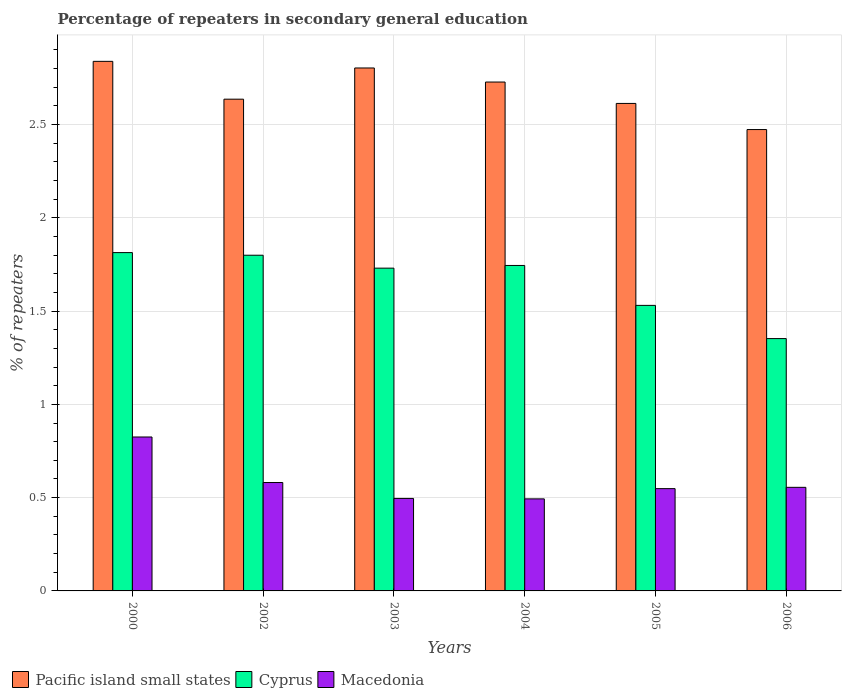How many different coloured bars are there?
Provide a succinct answer. 3. How many groups of bars are there?
Give a very brief answer. 6. Are the number of bars per tick equal to the number of legend labels?
Give a very brief answer. Yes. Are the number of bars on each tick of the X-axis equal?
Your answer should be very brief. Yes. What is the label of the 1st group of bars from the left?
Your answer should be compact. 2000. What is the percentage of repeaters in secondary general education in Pacific island small states in 2004?
Offer a very short reply. 2.73. Across all years, what is the maximum percentage of repeaters in secondary general education in Cyprus?
Your answer should be very brief. 1.81. Across all years, what is the minimum percentage of repeaters in secondary general education in Macedonia?
Keep it short and to the point. 0.49. In which year was the percentage of repeaters in secondary general education in Pacific island small states maximum?
Ensure brevity in your answer.  2000. What is the total percentage of repeaters in secondary general education in Pacific island small states in the graph?
Your answer should be compact. 16.09. What is the difference between the percentage of repeaters in secondary general education in Macedonia in 2004 and that in 2005?
Offer a very short reply. -0.05. What is the difference between the percentage of repeaters in secondary general education in Macedonia in 2002 and the percentage of repeaters in secondary general education in Pacific island small states in 2004?
Offer a terse response. -2.15. What is the average percentage of repeaters in secondary general education in Macedonia per year?
Offer a very short reply. 0.58. In the year 2000, what is the difference between the percentage of repeaters in secondary general education in Cyprus and percentage of repeaters in secondary general education in Pacific island small states?
Ensure brevity in your answer.  -1.03. What is the ratio of the percentage of repeaters in secondary general education in Pacific island small states in 2002 to that in 2003?
Ensure brevity in your answer.  0.94. Is the percentage of repeaters in secondary general education in Cyprus in 2004 less than that in 2005?
Your answer should be very brief. No. What is the difference between the highest and the second highest percentage of repeaters in secondary general education in Cyprus?
Give a very brief answer. 0.01. What is the difference between the highest and the lowest percentage of repeaters in secondary general education in Pacific island small states?
Ensure brevity in your answer.  0.37. In how many years, is the percentage of repeaters in secondary general education in Cyprus greater than the average percentage of repeaters in secondary general education in Cyprus taken over all years?
Make the answer very short. 4. What does the 3rd bar from the left in 2002 represents?
Offer a very short reply. Macedonia. What does the 3rd bar from the right in 2003 represents?
Offer a terse response. Pacific island small states. Is it the case that in every year, the sum of the percentage of repeaters in secondary general education in Cyprus and percentage of repeaters in secondary general education in Pacific island small states is greater than the percentage of repeaters in secondary general education in Macedonia?
Your response must be concise. Yes. How many bars are there?
Ensure brevity in your answer.  18. Are the values on the major ticks of Y-axis written in scientific E-notation?
Offer a terse response. No. Does the graph contain any zero values?
Make the answer very short. No. Where does the legend appear in the graph?
Make the answer very short. Bottom left. How many legend labels are there?
Your answer should be compact. 3. What is the title of the graph?
Your response must be concise. Percentage of repeaters in secondary general education. Does "Malaysia" appear as one of the legend labels in the graph?
Offer a terse response. No. What is the label or title of the Y-axis?
Give a very brief answer. % of repeaters. What is the % of repeaters of Pacific island small states in 2000?
Keep it short and to the point. 2.84. What is the % of repeaters of Cyprus in 2000?
Provide a succinct answer. 1.81. What is the % of repeaters of Macedonia in 2000?
Offer a terse response. 0.83. What is the % of repeaters in Pacific island small states in 2002?
Give a very brief answer. 2.64. What is the % of repeaters of Cyprus in 2002?
Provide a short and direct response. 1.8. What is the % of repeaters of Macedonia in 2002?
Provide a short and direct response. 0.58. What is the % of repeaters of Pacific island small states in 2003?
Ensure brevity in your answer.  2.8. What is the % of repeaters of Cyprus in 2003?
Ensure brevity in your answer.  1.73. What is the % of repeaters of Macedonia in 2003?
Provide a short and direct response. 0.5. What is the % of repeaters in Pacific island small states in 2004?
Make the answer very short. 2.73. What is the % of repeaters of Cyprus in 2004?
Keep it short and to the point. 1.74. What is the % of repeaters in Macedonia in 2004?
Provide a succinct answer. 0.49. What is the % of repeaters in Pacific island small states in 2005?
Give a very brief answer. 2.61. What is the % of repeaters of Cyprus in 2005?
Ensure brevity in your answer.  1.53. What is the % of repeaters of Macedonia in 2005?
Give a very brief answer. 0.55. What is the % of repeaters in Pacific island small states in 2006?
Ensure brevity in your answer.  2.47. What is the % of repeaters in Cyprus in 2006?
Offer a terse response. 1.35. What is the % of repeaters in Macedonia in 2006?
Provide a succinct answer. 0.56. Across all years, what is the maximum % of repeaters in Pacific island small states?
Keep it short and to the point. 2.84. Across all years, what is the maximum % of repeaters of Cyprus?
Offer a very short reply. 1.81. Across all years, what is the maximum % of repeaters in Macedonia?
Provide a short and direct response. 0.83. Across all years, what is the minimum % of repeaters in Pacific island small states?
Offer a very short reply. 2.47. Across all years, what is the minimum % of repeaters of Cyprus?
Provide a short and direct response. 1.35. Across all years, what is the minimum % of repeaters in Macedonia?
Your answer should be compact. 0.49. What is the total % of repeaters in Pacific island small states in the graph?
Make the answer very short. 16.09. What is the total % of repeaters of Cyprus in the graph?
Give a very brief answer. 9.97. What is the total % of repeaters of Macedonia in the graph?
Make the answer very short. 3.5. What is the difference between the % of repeaters in Pacific island small states in 2000 and that in 2002?
Your response must be concise. 0.2. What is the difference between the % of repeaters of Cyprus in 2000 and that in 2002?
Provide a short and direct response. 0.01. What is the difference between the % of repeaters of Macedonia in 2000 and that in 2002?
Offer a very short reply. 0.24. What is the difference between the % of repeaters of Pacific island small states in 2000 and that in 2003?
Your answer should be compact. 0.04. What is the difference between the % of repeaters in Cyprus in 2000 and that in 2003?
Give a very brief answer. 0.08. What is the difference between the % of repeaters in Macedonia in 2000 and that in 2003?
Your response must be concise. 0.33. What is the difference between the % of repeaters in Pacific island small states in 2000 and that in 2004?
Provide a short and direct response. 0.11. What is the difference between the % of repeaters of Cyprus in 2000 and that in 2004?
Your answer should be compact. 0.07. What is the difference between the % of repeaters of Macedonia in 2000 and that in 2004?
Offer a very short reply. 0.33. What is the difference between the % of repeaters in Pacific island small states in 2000 and that in 2005?
Ensure brevity in your answer.  0.23. What is the difference between the % of repeaters in Cyprus in 2000 and that in 2005?
Your answer should be compact. 0.28. What is the difference between the % of repeaters in Macedonia in 2000 and that in 2005?
Give a very brief answer. 0.28. What is the difference between the % of repeaters of Pacific island small states in 2000 and that in 2006?
Give a very brief answer. 0.37. What is the difference between the % of repeaters in Cyprus in 2000 and that in 2006?
Offer a terse response. 0.46. What is the difference between the % of repeaters in Macedonia in 2000 and that in 2006?
Ensure brevity in your answer.  0.27. What is the difference between the % of repeaters of Pacific island small states in 2002 and that in 2003?
Make the answer very short. -0.17. What is the difference between the % of repeaters in Cyprus in 2002 and that in 2003?
Provide a short and direct response. 0.07. What is the difference between the % of repeaters of Macedonia in 2002 and that in 2003?
Offer a terse response. 0.09. What is the difference between the % of repeaters in Pacific island small states in 2002 and that in 2004?
Make the answer very short. -0.09. What is the difference between the % of repeaters in Cyprus in 2002 and that in 2004?
Provide a succinct answer. 0.05. What is the difference between the % of repeaters in Macedonia in 2002 and that in 2004?
Offer a very short reply. 0.09. What is the difference between the % of repeaters of Pacific island small states in 2002 and that in 2005?
Ensure brevity in your answer.  0.02. What is the difference between the % of repeaters of Cyprus in 2002 and that in 2005?
Provide a short and direct response. 0.27. What is the difference between the % of repeaters in Macedonia in 2002 and that in 2005?
Give a very brief answer. 0.03. What is the difference between the % of repeaters of Pacific island small states in 2002 and that in 2006?
Ensure brevity in your answer.  0.16. What is the difference between the % of repeaters in Cyprus in 2002 and that in 2006?
Offer a very short reply. 0.45. What is the difference between the % of repeaters of Macedonia in 2002 and that in 2006?
Provide a succinct answer. 0.03. What is the difference between the % of repeaters in Pacific island small states in 2003 and that in 2004?
Give a very brief answer. 0.08. What is the difference between the % of repeaters of Cyprus in 2003 and that in 2004?
Ensure brevity in your answer.  -0.01. What is the difference between the % of repeaters of Macedonia in 2003 and that in 2004?
Offer a very short reply. 0. What is the difference between the % of repeaters in Pacific island small states in 2003 and that in 2005?
Give a very brief answer. 0.19. What is the difference between the % of repeaters of Cyprus in 2003 and that in 2005?
Your answer should be compact. 0.2. What is the difference between the % of repeaters of Macedonia in 2003 and that in 2005?
Give a very brief answer. -0.05. What is the difference between the % of repeaters of Pacific island small states in 2003 and that in 2006?
Your answer should be very brief. 0.33. What is the difference between the % of repeaters in Cyprus in 2003 and that in 2006?
Your response must be concise. 0.38. What is the difference between the % of repeaters in Macedonia in 2003 and that in 2006?
Give a very brief answer. -0.06. What is the difference between the % of repeaters of Pacific island small states in 2004 and that in 2005?
Ensure brevity in your answer.  0.11. What is the difference between the % of repeaters of Cyprus in 2004 and that in 2005?
Keep it short and to the point. 0.21. What is the difference between the % of repeaters of Macedonia in 2004 and that in 2005?
Make the answer very short. -0.05. What is the difference between the % of repeaters of Pacific island small states in 2004 and that in 2006?
Your response must be concise. 0.25. What is the difference between the % of repeaters of Cyprus in 2004 and that in 2006?
Provide a short and direct response. 0.39. What is the difference between the % of repeaters of Macedonia in 2004 and that in 2006?
Your answer should be compact. -0.06. What is the difference between the % of repeaters of Pacific island small states in 2005 and that in 2006?
Your answer should be compact. 0.14. What is the difference between the % of repeaters in Cyprus in 2005 and that in 2006?
Provide a short and direct response. 0.18. What is the difference between the % of repeaters in Macedonia in 2005 and that in 2006?
Offer a very short reply. -0.01. What is the difference between the % of repeaters of Pacific island small states in 2000 and the % of repeaters of Cyprus in 2002?
Ensure brevity in your answer.  1.04. What is the difference between the % of repeaters in Pacific island small states in 2000 and the % of repeaters in Macedonia in 2002?
Keep it short and to the point. 2.26. What is the difference between the % of repeaters of Cyprus in 2000 and the % of repeaters of Macedonia in 2002?
Your response must be concise. 1.23. What is the difference between the % of repeaters in Pacific island small states in 2000 and the % of repeaters in Cyprus in 2003?
Ensure brevity in your answer.  1.11. What is the difference between the % of repeaters of Pacific island small states in 2000 and the % of repeaters of Macedonia in 2003?
Your response must be concise. 2.34. What is the difference between the % of repeaters in Cyprus in 2000 and the % of repeaters in Macedonia in 2003?
Offer a terse response. 1.32. What is the difference between the % of repeaters of Pacific island small states in 2000 and the % of repeaters of Cyprus in 2004?
Make the answer very short. 1.09. What is the difference between the % of repeaters of Pacific island small states in 2000 and the % of repeaters of Macedonia in 2004?
Your response must be concise. 2.35. What is the difference between the % of repeaters in Cyprus in 2000 and the % of repeaters in Macedonia in 2004?
Ensure brevity in your answer.  1.32. What is the difference between the % of repeaters of Pacific island small states in 2000 and the % of repeaters of Cyprus in 2005?
Your answer should be compact. 1.31. What is the difference between the % of repeaters of Pacific island small states in 2000 and the % of repeaters of Macedonia in 2005?
Keep it short and to the point. 2.29. What is the difference between the % of repeaters of Cyprus in 2000 and the % of repeaters of Macedonia in 2005?
Offer a very short reply. 1.26. What is the difference between the % of repeaters in Pacific island small states in 2000 and the % of repeaters in Cyprus in 2006?
Your answer should be very brief. 1.49. What is the difference between the % of repeaters of Pacific island small states in 2000 and the % of repeaters of Macedonia in 2006?
Make the answer very short. 2.28. What is the difference between the % of repeaters of Cyprus in 2000 and the % of repeaters of Macedonia in 2006?
Your answer should be compact. 1.26. What is the difference between the % of repeaters in Pacific island small states in 2002 and the % of repeaters in Cyprus in 2003?
Keep it short and to the point. 0.91. What is the difference between the % of repeaters of Pacific island small states in 2002 and the % of repeaters of Macedonia in 2003?
Offer a very short reply. 2.14. What is the difference between the % of repeaters in Cyprus in 2002 and the % of repeaters in Macedonia in 2003?
Provide a succinct answer. 1.3. What is the difference between the % of repeaters in Pacific island small states in 2002 and the % of repeaters in Cyprus in 2004?
Give a very brief answer. 0.89. What is the difference between the % of repeaters in Pacific island small states in 2002 and the % of repeaters in Macedonia in 2004?
Your answer should be very brief. 2.14. What is the difference between the % of repeaters of Cyprus in 2002 and the % of repeaters of Macedonia in 2004?
Your answer should be compact. 1.31. What is the difference between the % of repeaters in Pacific island small states in 2002 and the % of repeaters in Cyprus in 2005?
Make the answer very short. 1.11. What is the difference between the % of repeaters of Pacific island small states in 2002 and the % of repeaters of Macedonia in 2005?
Your response must be concise. 2.09. What is the difference between the % of repeaters in Cyprus in 2002 and the % of repeaters in Macedonia in 2005?
Provide a short and direct response. 1.25. What is the difference between the % of repeaters of Pacific island small states in 2002 and the % of repeaters of Cyprus in 2006?
Make the answer very short. 1.28. What is the difference between the % of repeaters in Pacific island small states in 2002 and the % of repeaters in Macedonia in 2006?
Provide a short and direct response. 2.08. What is the difference between the % of repeaters in Cyprus in 2002 and the % of repeaters in Macedonia in 2006?
Provide a succinct answer. 1.24. What is the difference between the % of repeaters of Pacific island small states in 2003 and the % of repeaters of Cyprus in 2004?
Give a very brief answer. 1.06. What is the difference between the % of repeaters in Pacific island small states in 2003 and the % of repeaters in Macedonia in 2004?
Make the answer very short. 2.31. What is the difference between the % of repeaters of Cyprus in 2003 and the % of repeaters of Macedonia in 2004?
Keep it short and to the point. 1.24. What is the difference between the % of repeaters in Pacific island small states in 2003 and the % of repeaters in Cyprus in 2005?
Your answer should be compact. 1.27. What is the difference between the % of repeaters of Pacific island small states in 2003 and the % of repeaters of Macedonia in 2005?
Your answer should be very brief. 2.25. What is the difference between the % of repeaters of Cyprus in 2003 and the % of repeaters of Macedonia in 2005?
Ensure brevity in your answer.  1.18. What is the difference between the % of repeaters in Pacific island small states in 2003 and the % of repeaters in Cyprus in 2006?
Your answer should be compact. 1.45. What is the difference between the % of repeaters in Pacific island small states in 2003 and the % of repeaters in Macedonia in 2006?
Provide a short and direct response. 2.25. What is the difference between the % of repeaters in Cyprus in 2003 and the % of repeaters in Macedonia in 2006?
Offer a very short reply. 1.17. What is the difference between the % of repeaters of Pacific island small states in 2004 and the % of repeaters of Cyprus in 2005?
Offer a very short reply. 1.2. What is the difference between the % of repeaters in Pacific island small states in 2004 and the % of repeaters in Macedonia in 2005?
Your response must be concise. 2.18. What is the difference between the % of repeaters of Cyprus in 2004 and the % of repeaters of Macedonia in 2005?
Provide a short and direct response. 1.2. What is the difference between the % of repeaters in Pacific island small states in 2004 and the % of repeaters in Cyprus in 2006?
Keep it short and to the point. 1.38. What is the difference between the % of repeaters of Pacific island small states in 2004 and the % of repeaters of Macedonia in 2006?
Provide a short and direct response. 2.17. What is the difference between the % of repeaters in Cyprus in 2004 and the % of repeaters in Macedonia in 2006?
Offer a terse response. 1.19. What is the difference between the % of repeaters in Pacific island small states in 2005 and the % of repeaters in Cyprus in 2006?
Provide a succinct answer. 1.26. What is the difference between the % of repeaters in Pacific island small states in 2005 and the % of repeaters in Macedonia in 2006?
Make the answer very short. 2.06. What is the difference between the % of repeaters in Cyprus in 2005 and the % of repeaters in Macedonia in 2006?
Keep it short and to the point. 0.98. What is the average % of repeaters in Pacific island small states per year?
Provide a short and direct response. 2.68. What is the average % of repeaters of Cyprus per year?
Ensure brevity in your answer.  1.66. What is the average % of repeaters of Macedonia per year?
Provide a succinct answer. 0.58. In the year 2000, what is the difference between the % of repeaters of Pacific island small states and % of repeaters of Cyprus?
Keep it short and to the point. 1.02. In the year 2000, what is the difference between the % of repeaters in Pacific island small states and % of repeaters in Macedonia?
Your response must be concise. 2.01. In the year 2000, what is the difference between the % of repeaters of Cyprus and % of repeaters of Macedonia?
Keep it short and to the point. 0.99. In the year 2002, what is the difference between the % of repeaters of Pacific island small states and % of repeaters of Cyprus?
Keep it short and to the point. 0.84. In the year 2002, what is the difference between the % of repeaters of Pacific island small states and % of repeaters of Macedonia?
Your answer should be very brief. 2.05. In the year 2002, what is the difference between the % of repeaters of Cyprus and % of repeaters of Macedonia?
Ensure brevity in your answer.  1.22. In the year 2003, what is the difference between the % of repeaters of Pacific island small states and % of repeaters of Cyprus?
Ensure brevity in your answer.  1.07. In the year 2003, what is the difference between the % of repeaters in Pacific island small states and % of repeaters in Macedonia?
Keep it short and to the point. 2.31. In the year 2003, what is the difference between the % of repeaters in Cyprus and % of repeaters in Macedonia?
Provide a short and direct response. 1.23. In the year 2004, what is the difference between the % of repeaters in Pacific island small states and % of repeaters in Macedonia?
Make the answer very short. 2.23. In the year 2004, what is the difference between the % of repeaters of Cyprus and % of repeaters of Macedonia?
Offer a very short reply. 1.25. In the year 2005, what is the difference between the % of repeaters in Pacific island small states and % of repeaters in Cyprus?
Provide a short and direct response. 1.08. In the year 2005, what is the difference between the % of repeaters in Pacific island small states and % of repeaters in Macedonia?
Offer a very short reply. 2.06. In the year 2005, what is the difference between the % of repeaters of Cyprus and % of repeaters of Macedonia?
Provide a short and direct response. 0.98. In the year 2006, what is the difference between the % of repeaters in Pacific island small states and % of repeaters in Cyprus?
Give a very brief answer. 1.12. In the year 2006, what is the difference between the % of repeaters of Pacific island small states and % of repeaters of Macedonia?
Your response must be concise. 1.92. In the year 2006, what is the difference between the % of repeaters in Cyprus and % of repeaters in Macedonia?
Ensure brevity in your answer.  0.8. What is the ratio of the % of repeaters in Cyprus in 2000 to that in 2002?
Offer a very short reply. 1.01. What is the ratio of the % of repeaters in Macedonia in 2000 to that in 2002?
Offer a terse response. 1.42. What is the ratio of the % of repeaters in Pacific island small states in 2000 to that in 2003?
Your answer should be compact. 1.01. What is the ratio of the % of repeaters of Cyprus in 2000 to that in 2003?
Your response must be concise. 1.05. What is the ratio of the % of repeaters of Macedonia in 2000 to that in 2003?
Ensure brevity in your answer.  1.66. What is the ratio of the % of repeaters in Pacific island small states in 2000 to that in 2004?
Your answer should be very brief. 1.04. What is the ratio of the % of repeaters of Cyprus in 2000 to that in 2004?
Offer a very short reply. 1.04. What is the ratio of the % of repeaters of Macedonia in 2000 to that in 2004?
Offer a terse response. 1.67. What is the ratio of the % of repeaters of Pacific island small states in 2000 to that in 2005?
Offer a very short reply. 1.09. What is the ratio of the % of repeaters of Cyprus in 2000 to that in 2005?
Ensure brevity in your answer.  1.18. What is the ratio of the % of repeaters of Macedonia in 2000 to that in 2005?
Provide a short and direct response. 1.5. What is the ratio of the % of repeaters of Pacific island small states in 2000 to that in 2006?
Make the answer very short. 1.15. What is the ratio of the % of repeaters of Cyprus in 2000 to that in 2006?
Provide a short and direct response. 1.34. What is the ratio of the % of repeaters in Macedonia in 2000 to that in 2006?
Offer a very short reply. 1.49. What is the ratio of the % of repeaters of Pacific island small states in 2002 to that in 2003?
Provide a succinct answer. 0.94. What is the ratio of the % of repeaters in Cyprus in 2002 to that in 2003?
Ensure brevity in your answer.  1.04. What is the ratio of the % of repeaters in Macedonia in 2002 to that in 2003?
Your answer should be compact. 1.17. What is the ratio of the % of repeaters of Pacific island small states in 2002 to that in 2004?
Offer a terse response. 0.97. What is the ratio of the % of repeaters of Cyprus in 2002 to that in 2004?
Provide a short and direct response. 1.03. What is the ratio of the % of repeaters of Macedonia in 2002 to that in 2004?
Provide a short and direct response. 1.18. What is the ratio of the % of repeaters of Pacific island small states in 2002 to that in 2005?
Provide a succinct answer. 1.01. What is the ratio of the % of repeaters of Cyprus in 2002 to that in 2005?
Provide a short and direct response. 1.18. What is the ratio of the % of repeaters of Macedonia in 2002 to that in 2005?
Provide a succinct answer. 1.06. What is the ratio of the % of repeaters in Pacific island small states in 2002 to that in 2006?
Offer a terse response. 1.07. What is the ratio of the % of repeaters in Cyprus in 2002 to that in 2006?
Offer a very short reply. 1.33. What is the ratio of the % of repeaters in Macedonia in 2002 to that in 2006?
Ensure brevity in your answer.  1.05. What is the ratio of the % of repeaters of Pacific island small states in 2003 to that in 2004?
Your answer should be compact. 1.03. What is the ratio of the % of repeaters in Pacific island small states in 2003 to that in 2005?
Make the answer very short. 1.07. What is the ratio of the % of repeaters in Cyprus in 2003 to that in 2005?
Your answer should be very brief. 1.13. What is the ratio of the % of repeaters in Macedonia in 2003 to that in 2005?
Give a very brief answer. 0.9. What is the ratio of the % of repeaters in Pacific island small states in 2003 to that in 2006?
Give a very brief answer. 1.13. What is the ratio of the % of repeaters in Cyprus in 2003 to that in 2006?
Make the answer very short. 1.28. What is the ratio of the % of repeaters in Macedonia in 2003 to that in 2006?
Ensure brevity in your answer.  0.89. What is the ratio of the % of repeaters in Pacific island small states in 2004 to that in 2005?
Offer a terse response. 1.04. What is the ratio of the % of repeaters of Cyprus in 2004 to that in 2005?
Offer a very short reply. 1.14. What is the ratio of the % of repeaters in Macedonia in 2004 to that in 2005?
Ensure brevity in your answer.  0.9. What is the ratio of the % of repeaters of Pacific island small states in 2004 to that in 2006?
Make the answer very short. 1.1. What is the ratio of the % of repeaters in Cyprus in 2004 to that in 2006?
Ensure brevity in your answer.  1.29. What is the ratio of the % of repeaters of Macedonia in 2004 to that in 2006?
Your answer should be very brief. 0.89. What is the ratio of the % of repeaters of Pacific island small states in 2005 to that in 2006?
Offer a terse response. 1.06. What is the ratio of the % of repeaters in Cyprus in 2005 to that in 2006?
Offer a terse response. 1.13. What is the ratio of the % of repeaters in Macedonia in 2005 to that in 2006?
Provide a short and direct response. 0.99. What is the difference between the highest and the second highest % of repeaters in Pacific island small states?
Keep it short and to the point. 0.04. What is the difference between the highest and the second highest % of repeaters of Cyprus?
Your answer should be compact. 0.01. What is the difference between the highest and the second highest % of repeaters in Macedonia?
Ensure brevity in your answer.  0.24. What is the difference between the highest and the lowest % of repeaters in Pacific island small states?
Offer a terse response. 0.37. What is the difference between the highest and the lowest % of repeaters in Cyprus?
Ensure brevity in your answer.  0.46. What is the difference between the highest and the lowest % of repeaters of Macedonia?
Ensure brevity in your answer.  0.33. 